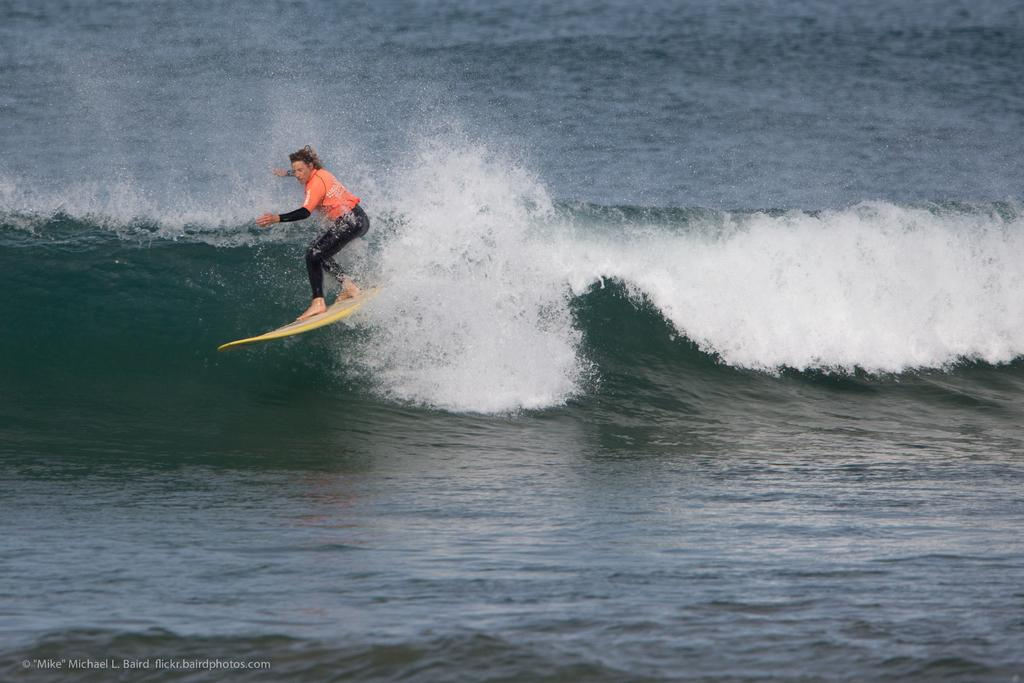Who or what is the main subject in the image? There is a person in the image. What is the person holding in the image? The person is holding a surfboard. Can you describe the person's attire in the image? The person is wearing a black and orange dress. Where is the person located in the image? The person is in the water. What type of branch can be seen in the person's hair in the image? There is no branch visible in the person's hair in the image. 